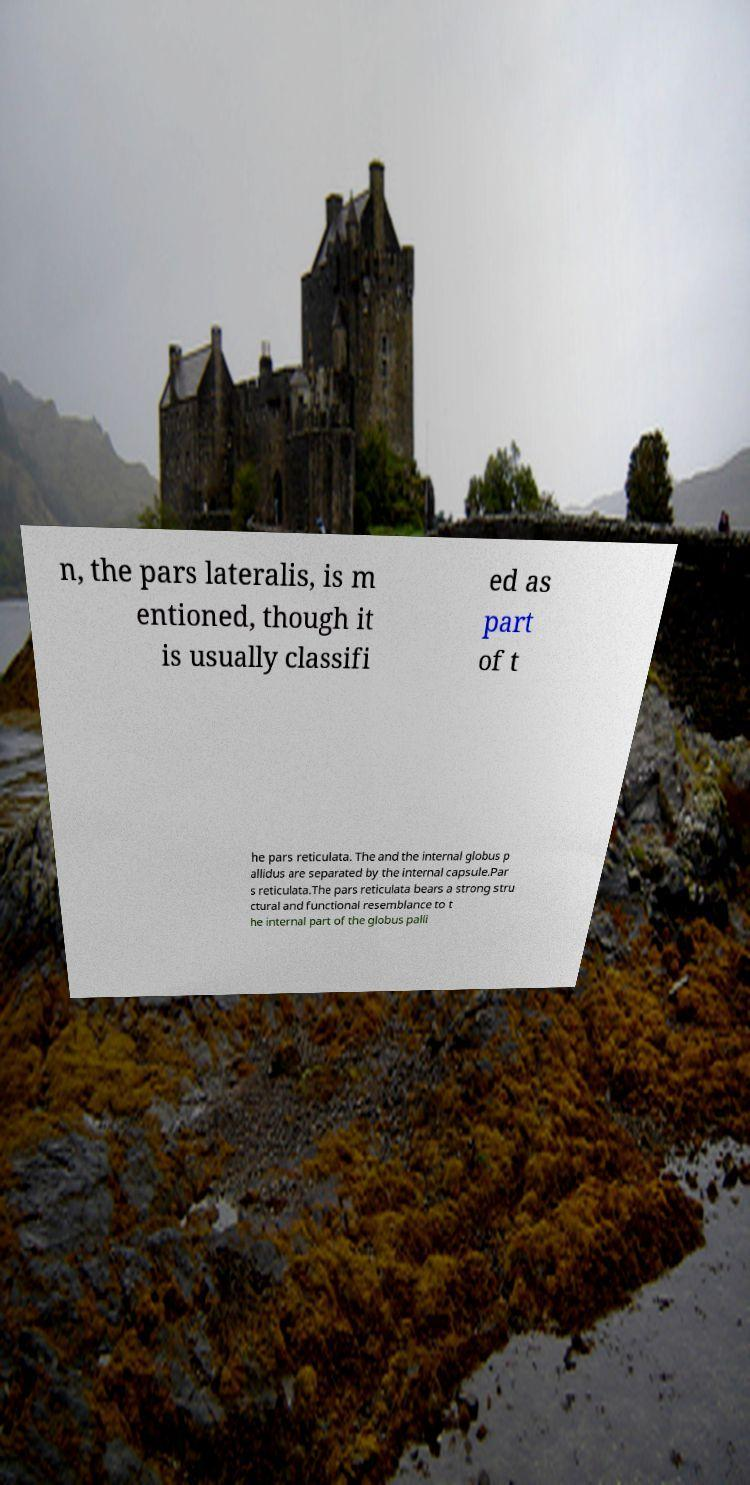Could you extract and type out the text from this image? n, the pars lateralis, is m entioned, though it is usually classifi ed as part of t he pars reticulata. The and the internal globus p allidus are separated by the internal capsule.Par s reticulata.The pars reticulata bears a strong stru ctural and functional resemblance to t he internal part of the globus palli 